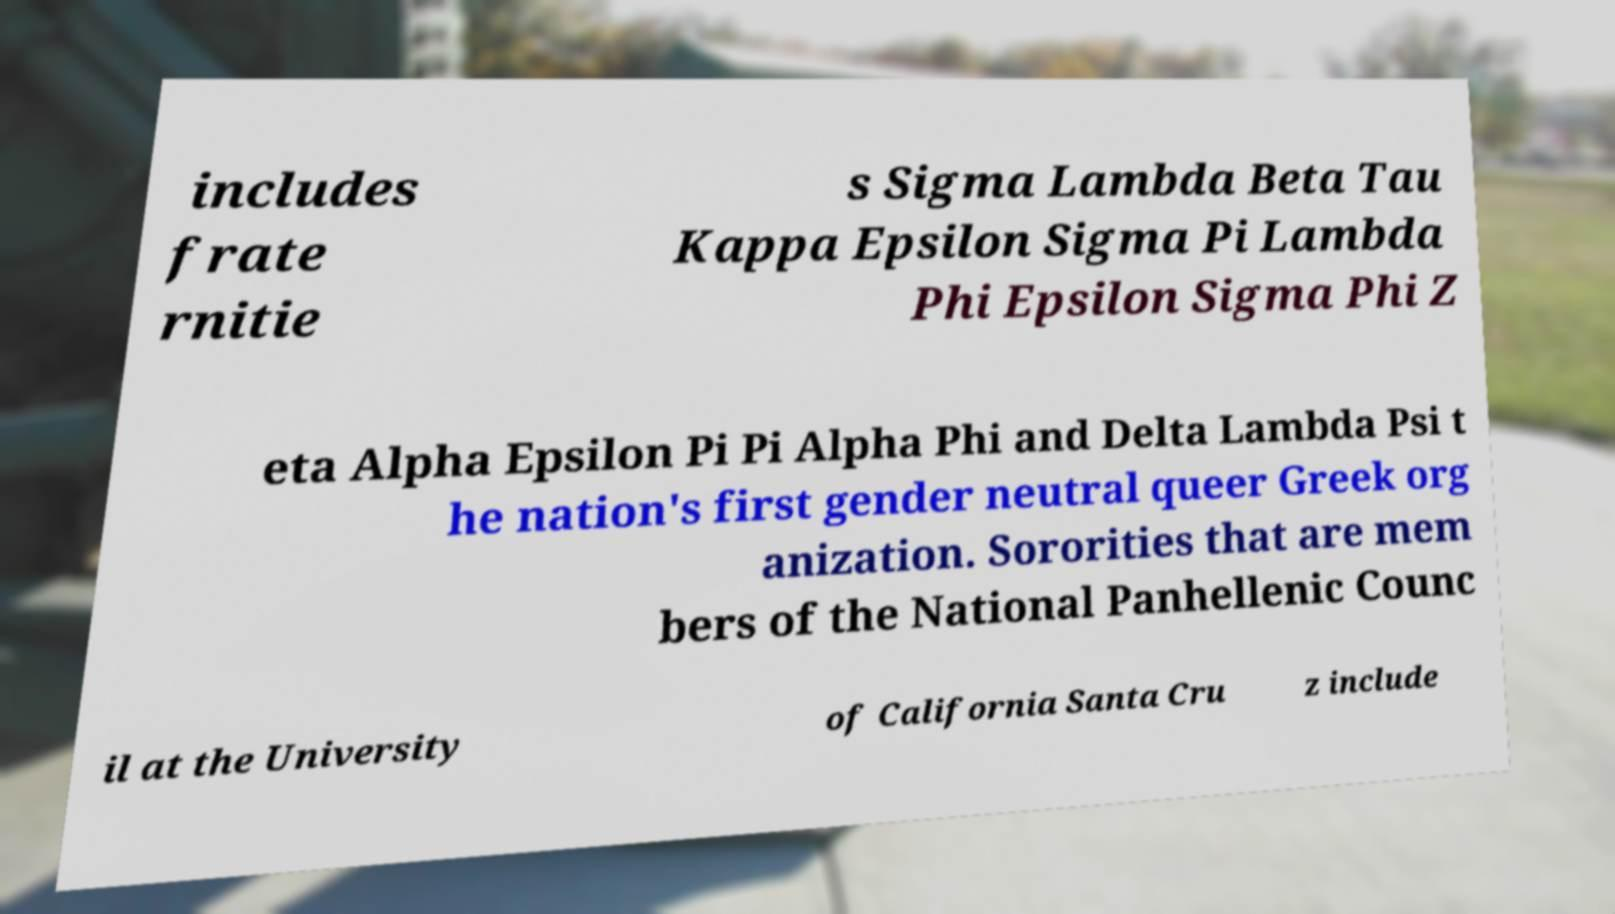For documentation purposes, I need the text within this image transcribed. Could you provide that? includes frate rnitie s Sigma Lambda Beta Tau Kappa Epsilon Sigma Pi Lambda Phi Epsilon Sigma Phi Z eta Alpha Epsilon Pi Pi Alpha Phi and Delta Lambda Psi t he nation's first gender neutral queer Greek org anization. Sororities that are mem bers of the National Panhellenic Counc il at the University of California Santa Cru z include 